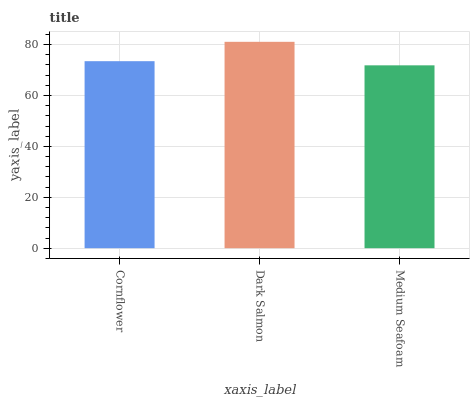Is Medium Seafoam the minimum?
Answer yes or no. Yes. Is Dark Salmon the maximum?
Answer yes or no. Yes. Is Dark Salmon the minimum?
Answer yes or no. No. Is Medium Seafoam the maximum?
Answer yes or no. No. Is Dark Salmon greater than Medium Seafoam?
Answer yes or no. Yes. Is Medium Seafoam less than Dark Salmon?
Answer yes or no. Yes. Is Medium Seafoam greater than Dark Salmon?
Answer yes or no. No. Is Dark Salmon less than Medium Seafoam?
Answer yes or no. No. Is Cornflower the high median?
Answer yes or no. Yes. Is Cornflower the low median?
Answer yes or no. Yes. Is Dark Salmon the high median?
Answer yes or no. No. Is Dark Salmon the low median?
Answer yes or no. No. 